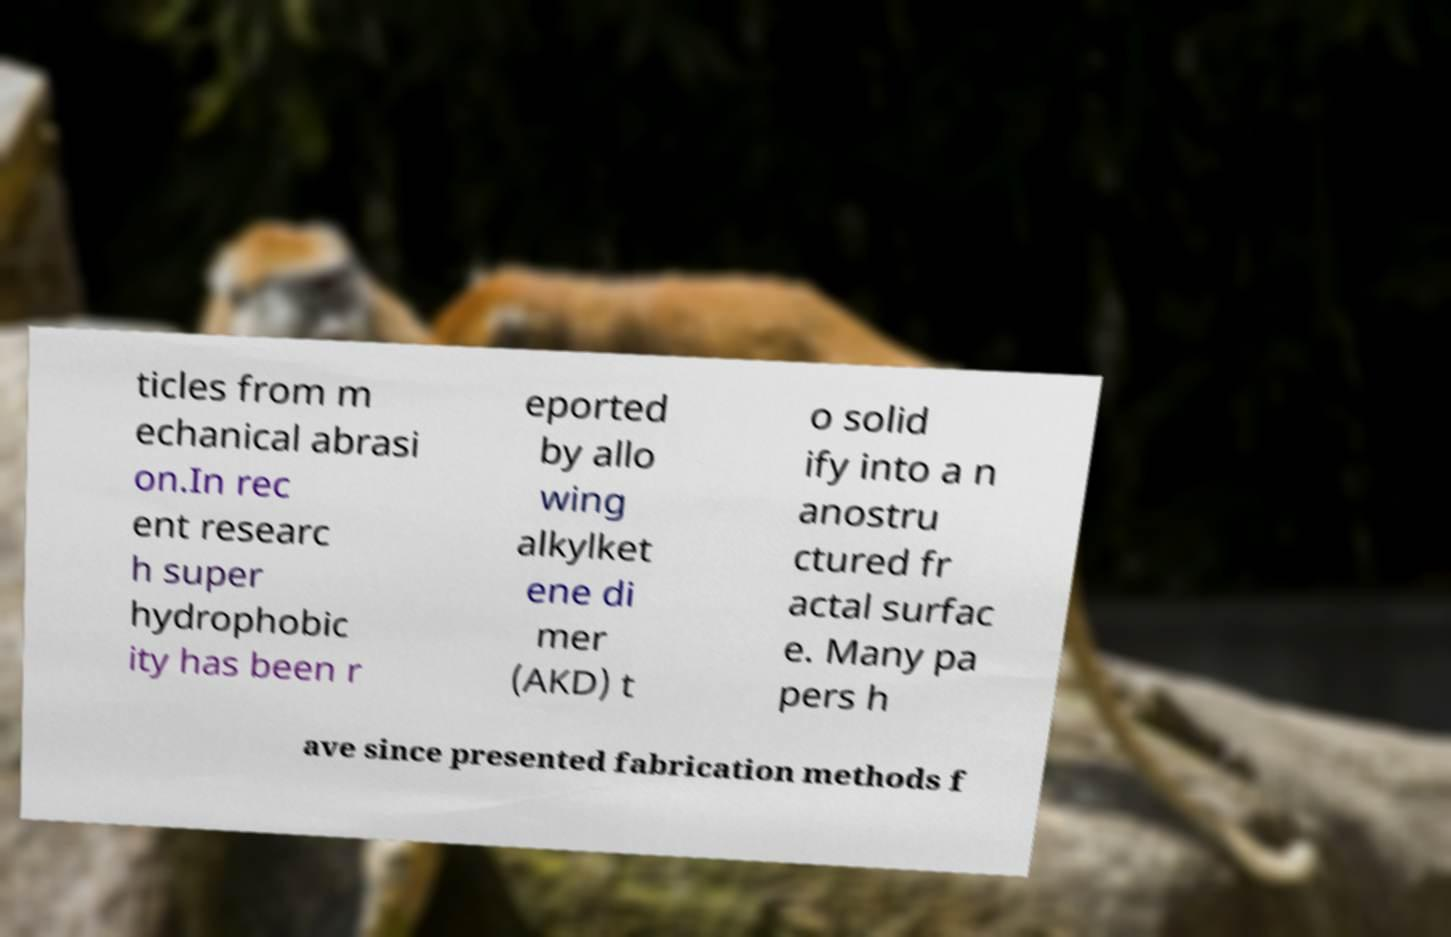What messages or text are displayed in this image? I need them in a readable, typed format. ticles from m echanical abrasi on.In rec ent researc h super hydrophobic ity has been r eported by allo wing alkylket ene di mer (AKD) t o solid ify into a n anostru ctured fr actal surfac e. Many pa pers h ave since presented fabrication methods f 